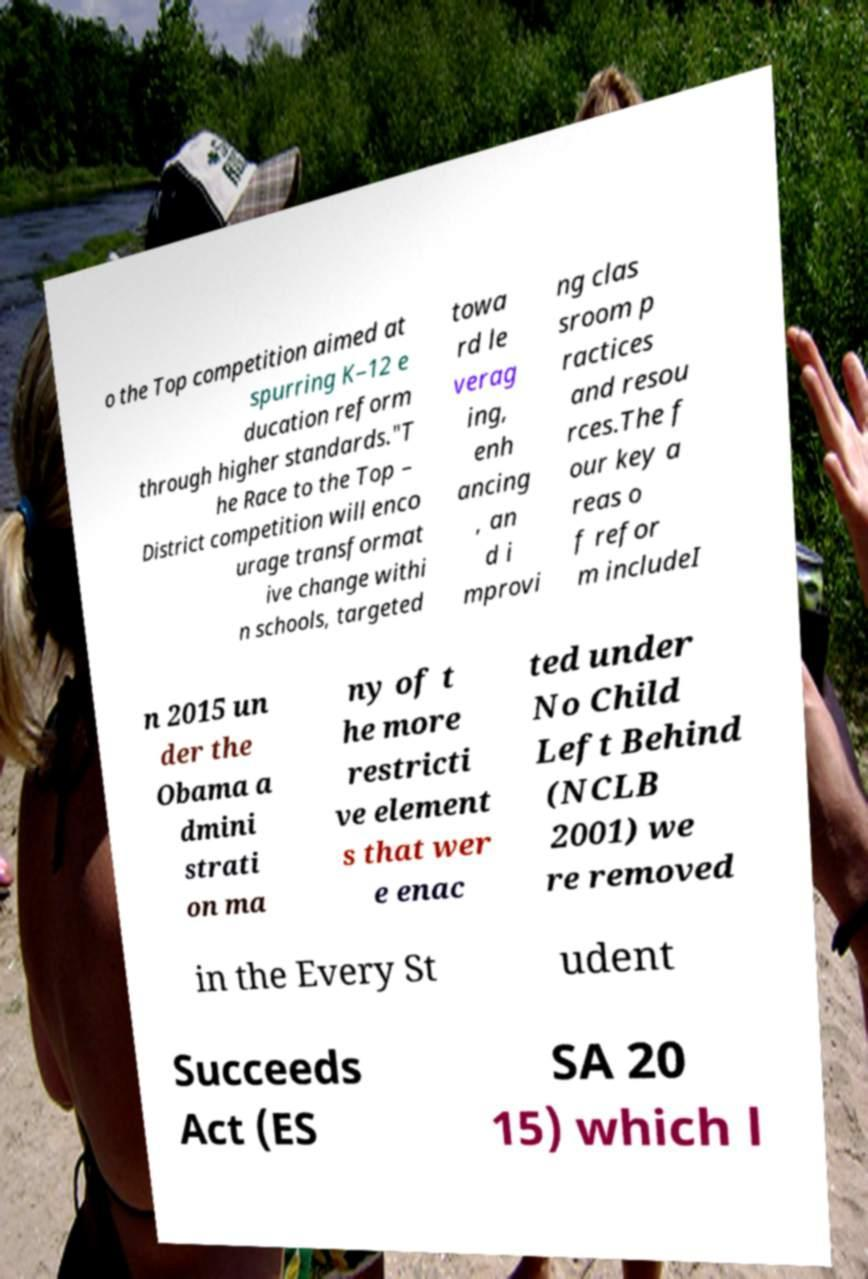Can you accurately transcribe the text from the provided image for me? o the Top competition aimed at spurring K–12 e ducation reform through higher standards."T he Race to the Top – District competition will enco urage transformat ive change withi n schools, targeted towa rd le verag ing, enh ancing , an d i mprovi ng clas sroom p ractices and resou rces.The f our key a reas o f refor m includeI n 2015 un der the Obama a dmini strati on ma ny of t he more restricti ve element s that wer e enac ted under No Child Left Behind (NCLB 2001) we re removed in the Every St udent Succeeds Act (ES SA 20 15) which l 